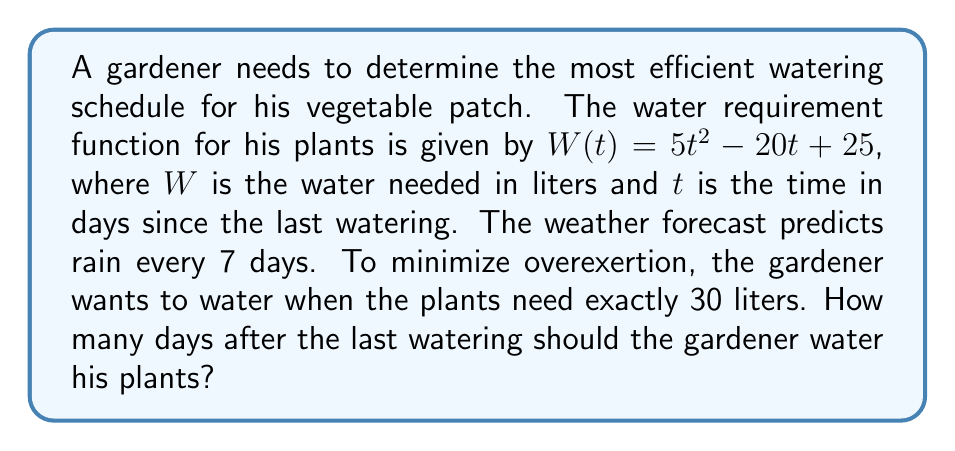Provide a solution to this math problem. To solve this problem, we need to follow these steps:

1) We're looking for the time $t$ when $W(t) = 30$ liters.

2) Set up the equation:
   $W(t) = 30$
   $5t^2 - 20t + 25 = 30$

3) Rearrange the equation:
   $5t^2 - 20t - 5 = 0$

4) This is a quadratic equation. We can solve it using the quadratic formula:
   $t = \frac{-b \pm \sqrt{b^2 - 4ac}}{2a}$

   Where $a = 5$, $b = -20$, and $c = -5$

5) Substituting these values:
   $t = \frac{20 \pm \sqrt{(-20)^2 - 4(5)(-5)}}{2(5)}$
   $= \frac{20 \pm \sqrt{400 + 100}}{10}$
   $= \frac{20 \pm \sqrt{500}}{10}$
   $= \frac{20 \pm 10\sqrt{5}}{10}$
   $= 2 \pm \sqrt{5}$

6) This gives us two solutions:
   $t_1 = 2 + \sqrt{5} \approx 4.24$ days
   $t_2 = 2 - \sqrt{5} \approx -0.24$ days

7) Since time cannot be negative, we discard the negative solution.

8) The positive solution (4.24 days) is less than the 7-day rain cycle, so this is our answer.

To minimize strain, the gardener should water approximately 4.24 days after the last watering.
Answer: $2 + \sqrt{5}$ days (approximately 4.24 days) 